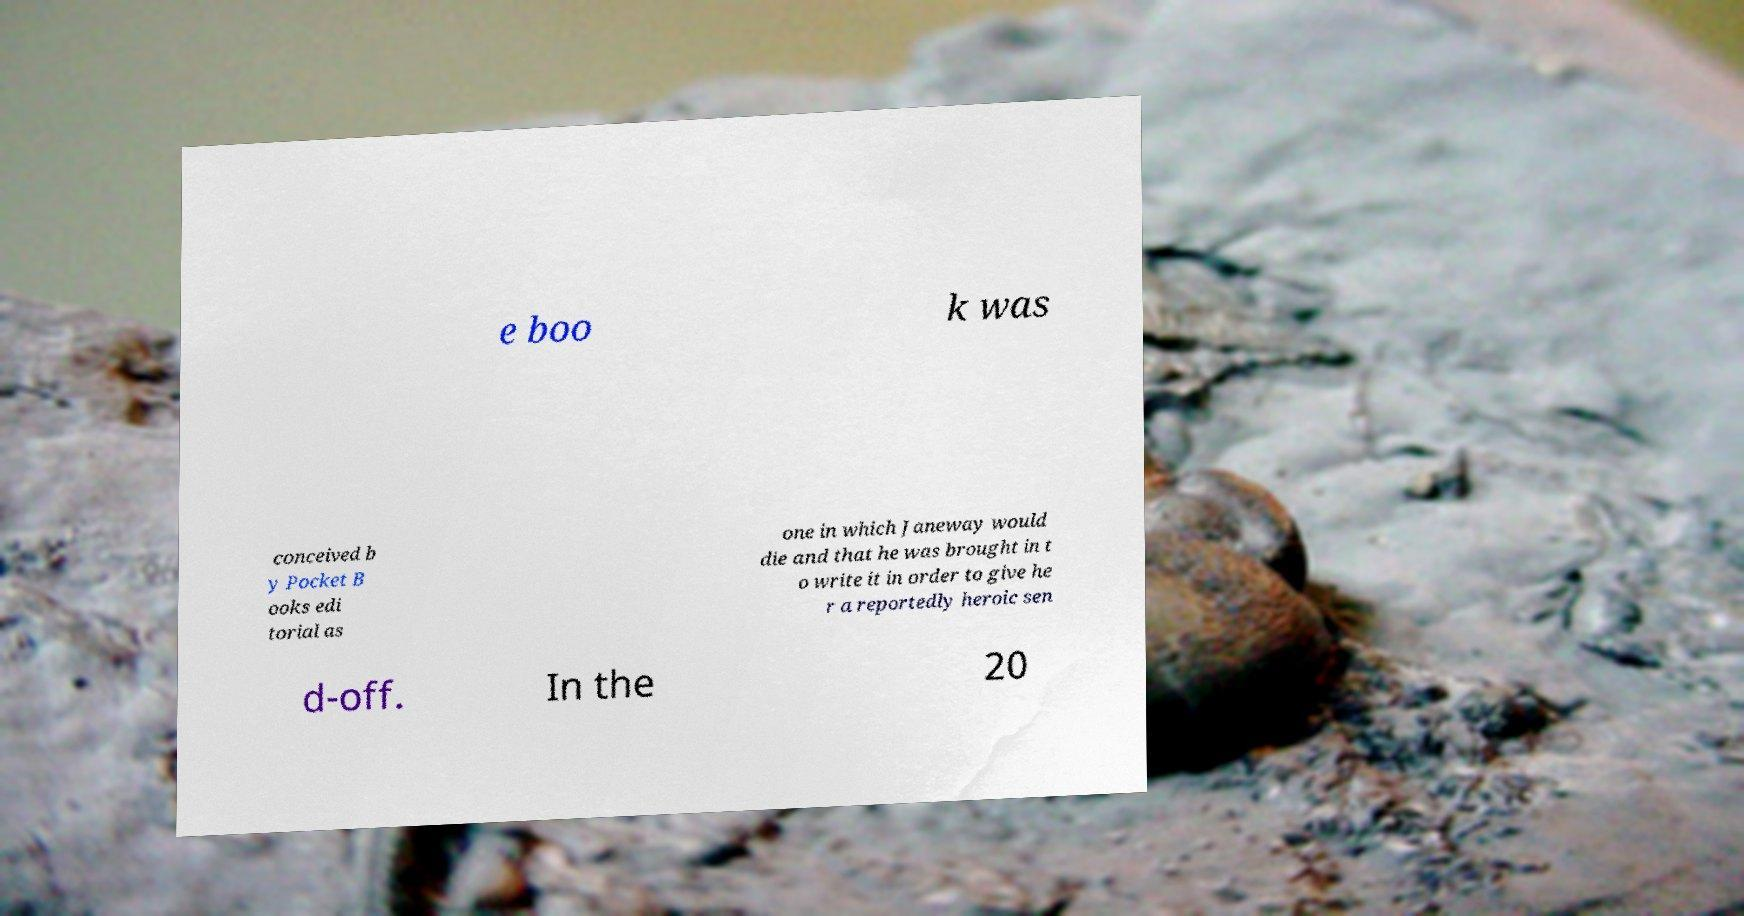There's text embedded in this image that I need extracted. Can you transcribe it verbatim? e boo k was conceived b y Pocket B ooks edi torial as one in which Janeway would die and that he was brought in t o write it in order to give he r a reportedly heroic sen d-off. In the 20 